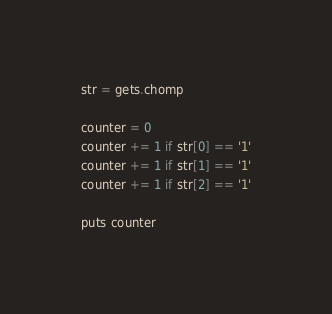<code> <loc_0><loc_0><loc_500><loc_500><_Ruby_>str = gets.chomp

counter = 0
counter += 1 if str[0] == '1'
counter += 1 if str[1] == '1'
counter += 1 if str[2] == '1'

puts counter</code> 